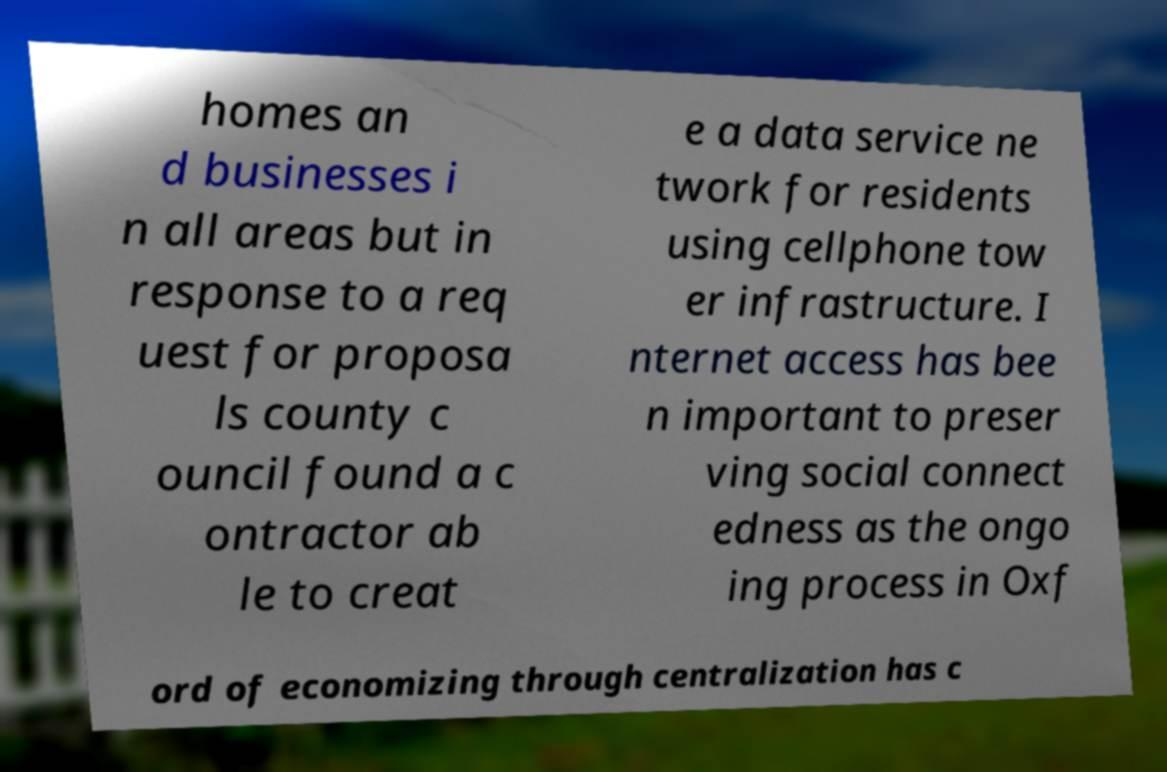Could you assist in decoding the text presented in this image and type it out clearly? homes an d businesses i n all areas but in response to a req uest for proposa ls county c ouncil found a c ontractor ab le to creat e a data service ne twork for residents using cellphone tow er infrastructure. I nternet access has bee n important to preser ving social connect edness as the ongo ing process in Oxf ord of economizing through centralization has c 